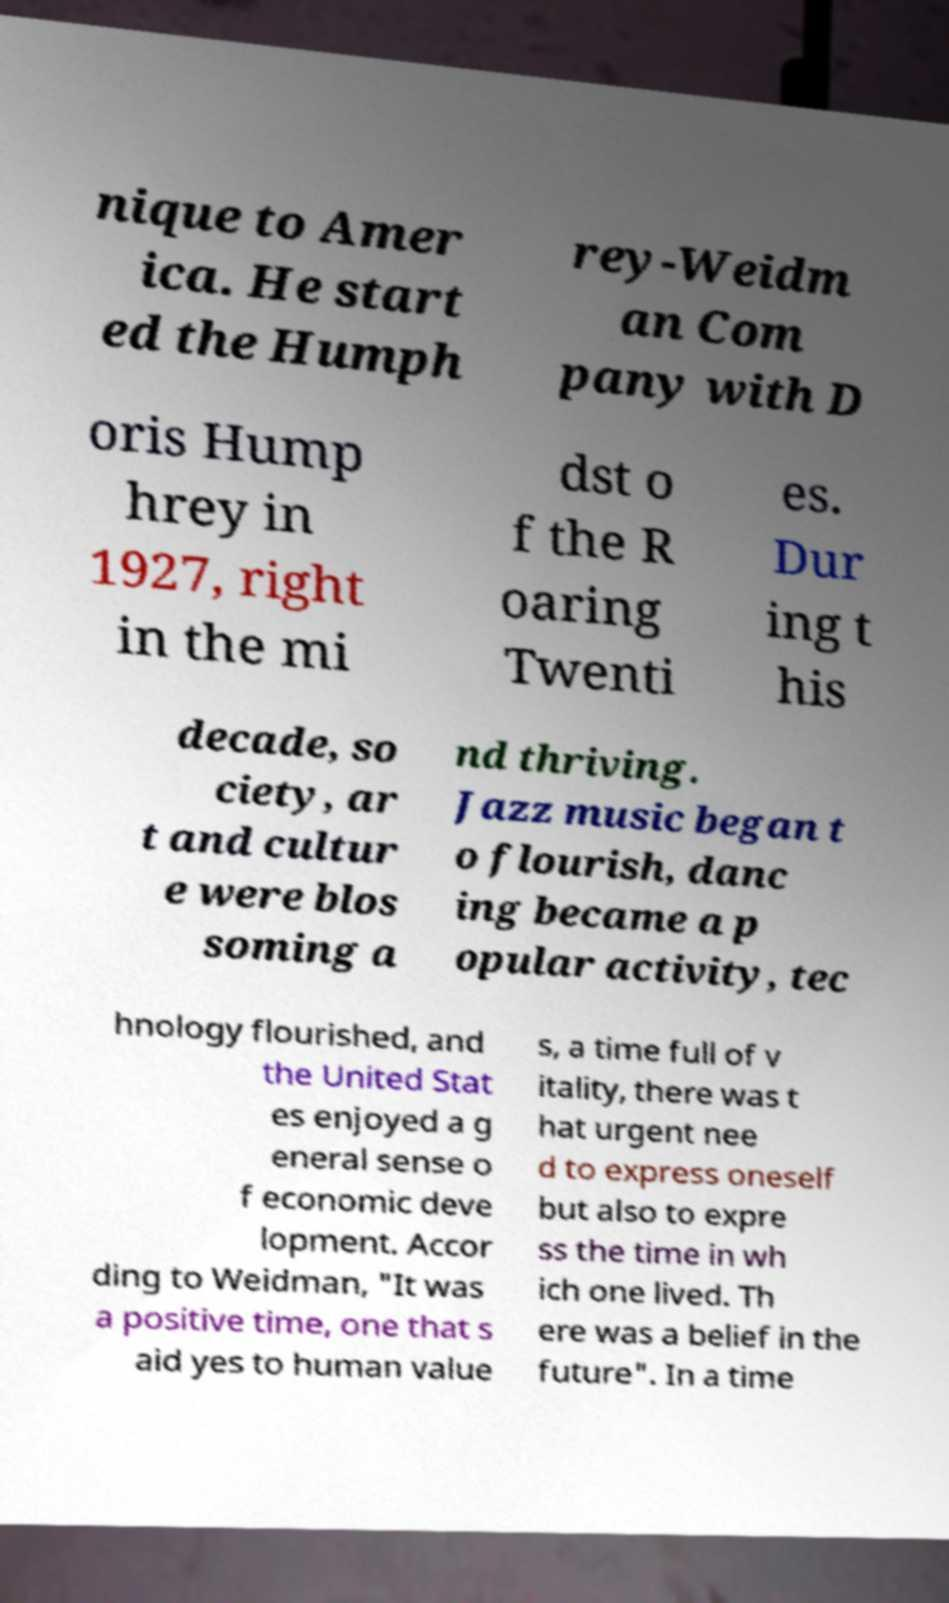What messages or text are displayed in this image? I need them in a readable, typed format. nique to Amer ica. He start ed the Humph rey-Weidm an Com pany with D oris Hump hrey in 1927, right in the mi dst o f the R oaring Twenti es. Dur ing t his decade, so ciety, ar t and cultur e were blos soming a nd thriving. Jazz music began t o flourish, danc ing became a p opular activity, tec hnology flourished, and the United Stat es enjoyed a g eneral sense o f economic deve lopment. Accor ding to Weidman, "It was a positive time, one that s aid yes to human value s, a time full of v itality, there was t hat urgent nee d to express oneself but also to expre ss the time in wh ich one lived. Th ere was a belief in the future". In a time 